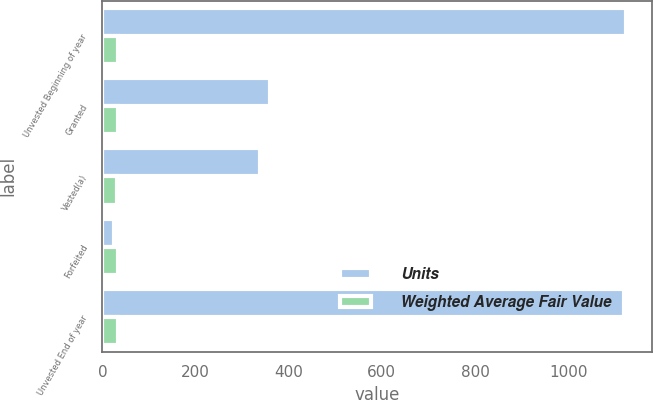Convert chart. <chart><loc_0><loc_0><loc_500><loc_500><stacked_bar_chart><ecel><fcel>Unvested Beginning of year<fcel>Granted<fcel>Vested(a)<fcel>Forfeited<fcel>Unvested End of year<nl><fcel>Units<fcel>1124<fcel>359<fcel>338<fcel>24<fcel>1121<nl><fcel>Weighted Average Fair Value<fcel>32.58<fcel>33.33<fcel>30.41<fcel>33.22<fcel>33.46<nl></chart> 